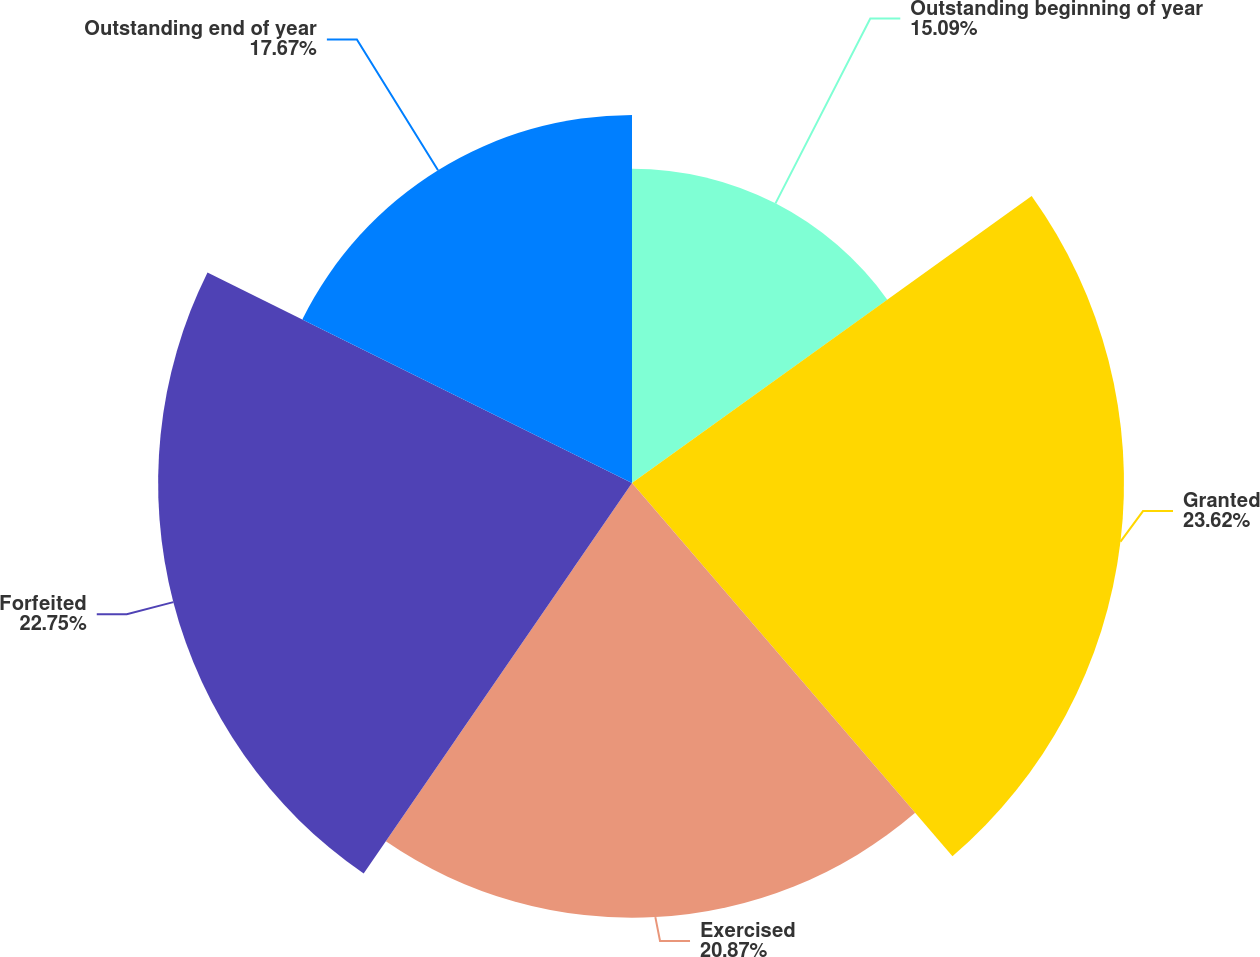<chart> <loc_0><loc_0><loc_500><loc_500><pie_chart><fcel>Outstanding beginning of year<fcel>Granted<fcel>Exercised<fcel>Forfeited<fcel>Outstanding end of year<nl><fcel>15.09%<fcel>23.62%<fcel>20.87%<fcel>22.75%<fcel>17.67%<nl></chart> 